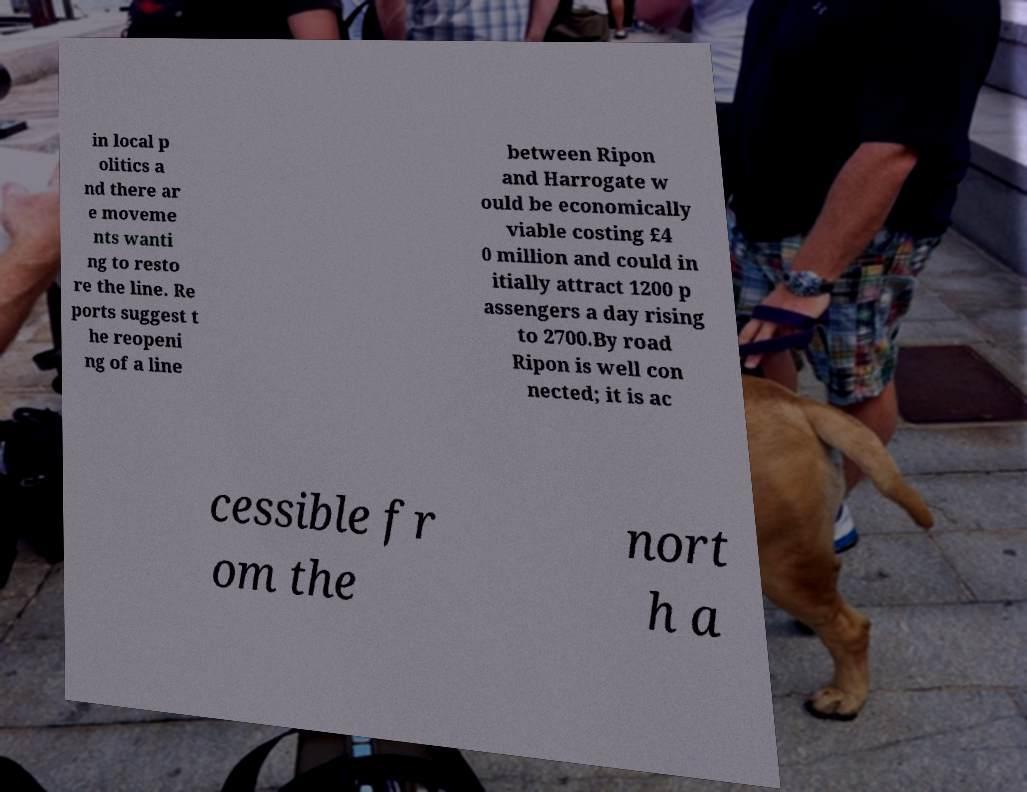Can you accurately transcribe the text from the provided image for me? in local p olitics a nd there ar e moveme nts wanti ng to resto re the line. Re ports suggest t he reopeni ng of a line between Ripon and Harrogate w ould be economically viable costing £4 0 million and could in itially attract 1200 p assengers a day rising to 2700.By road Ripon is well con nected; it is ac cessible fr om the nort h a 